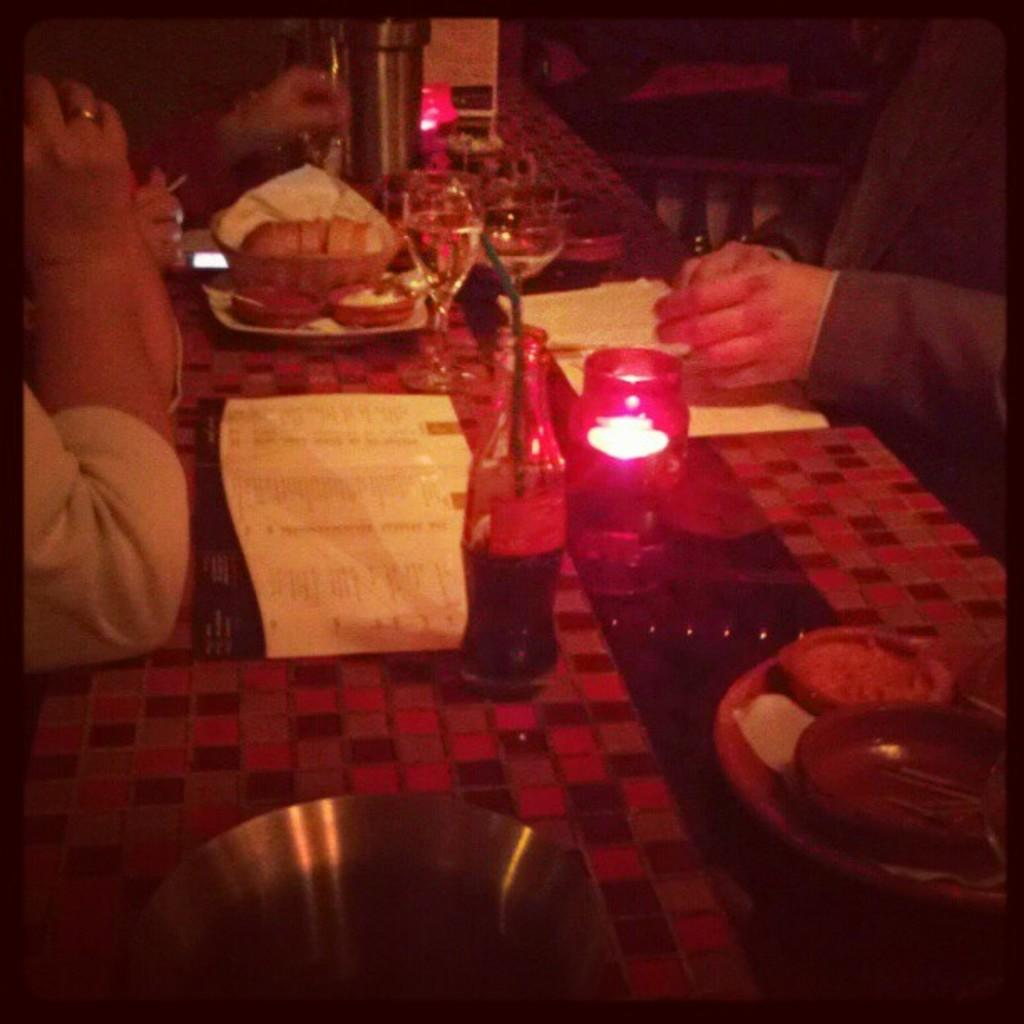How many people are in the image? There are persons in the image, but the exact number is not specified. What is the main piece of furniture in the image? There is a table in the image. What objects are on the table? There is a bottle, a lamp, paper, a tray, a bowl, food, and a plate on the table. What type of light source is on the table? There is a lamp on the table. What might be used for serving or holding food on the table? There is a tray on the table. What direction is the crate facing in the image? There is no crate present in the image. What type of collar is the person wearing in the image? There is no mention of a collar or any specific clothing worn by the persons in the image. 